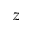<formula> <loc_0><loc_0><loc_500><loc_500>z</formula> 